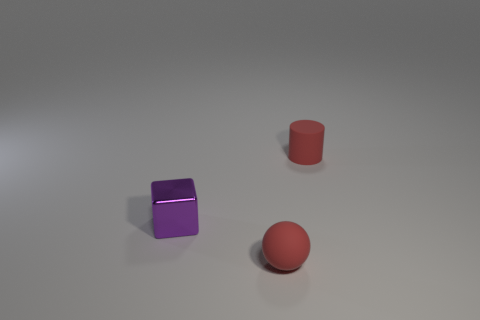Add 3 small cylinders. How many objects exist? 6 Subtract all blocks. How many objects are left? 2 Subtract 1 cylinders. How many cylinders are left? 0 Subtract 0 gray cylinders. How many objects are left? 3 Subtract all gray cylinders. Subtract all brown balls. How many cylinders are left? 1 Subtract all cyan metallic balls. Subtract all small purple metallic objects. How many objects are left? 2 Add 1 tiny purple blocks. How many tiny purple blocks are left? 2 Add 1 tiny metal cubes. How many tiny metal cubes exist? 2 